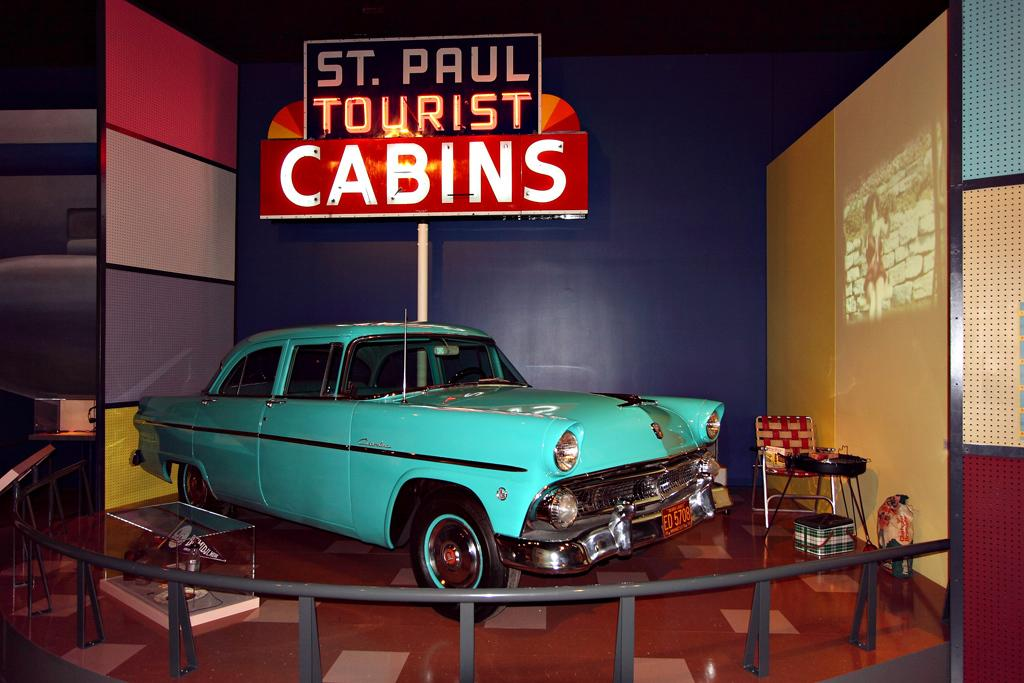What type of structure is visible in the image? There is a cabin in the image. What is placed inside the cabin? A car is placed inside the cabin. What is the purpose of the car in the cabin? The car is meant to showcase the cabin to people. What is written on the board in the image? The board is named "St Paul Tourist Cabins." Where is the board located in relation to the car? The board is located behind the car. What furniture can be seen on the right side of the image? There is a chair and a small table next to the chair. What type of voice can be heard coming from the car in the image? There is no voice coming from the car in the image. What type of religious symbolism is present in the image? There is no religious symbolism present in the image. What color are the eyes of the person sitting in the chair? There is no person sitting in the chair in the image. 